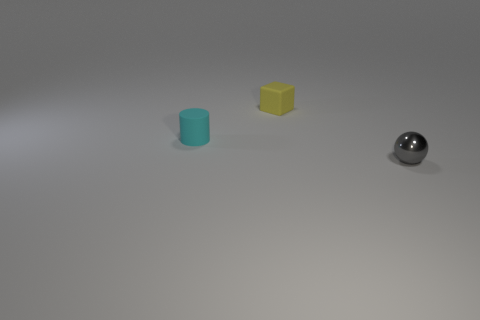Add 2 tiny cyan cylinders. How many objects exist? 5 Add 1 large yellow matte cylinders. How many large yellow matte cylinders exist? 1 Subtract 1 gray spheres. How many objects are left? 2 Subtract all cylinders. How many objects are left? 2 Subtract all small cylinders. Subtract all gray objects. How many objects are left? 1 Add 2 tiny spheres. How many tiny spheres are left? 3 